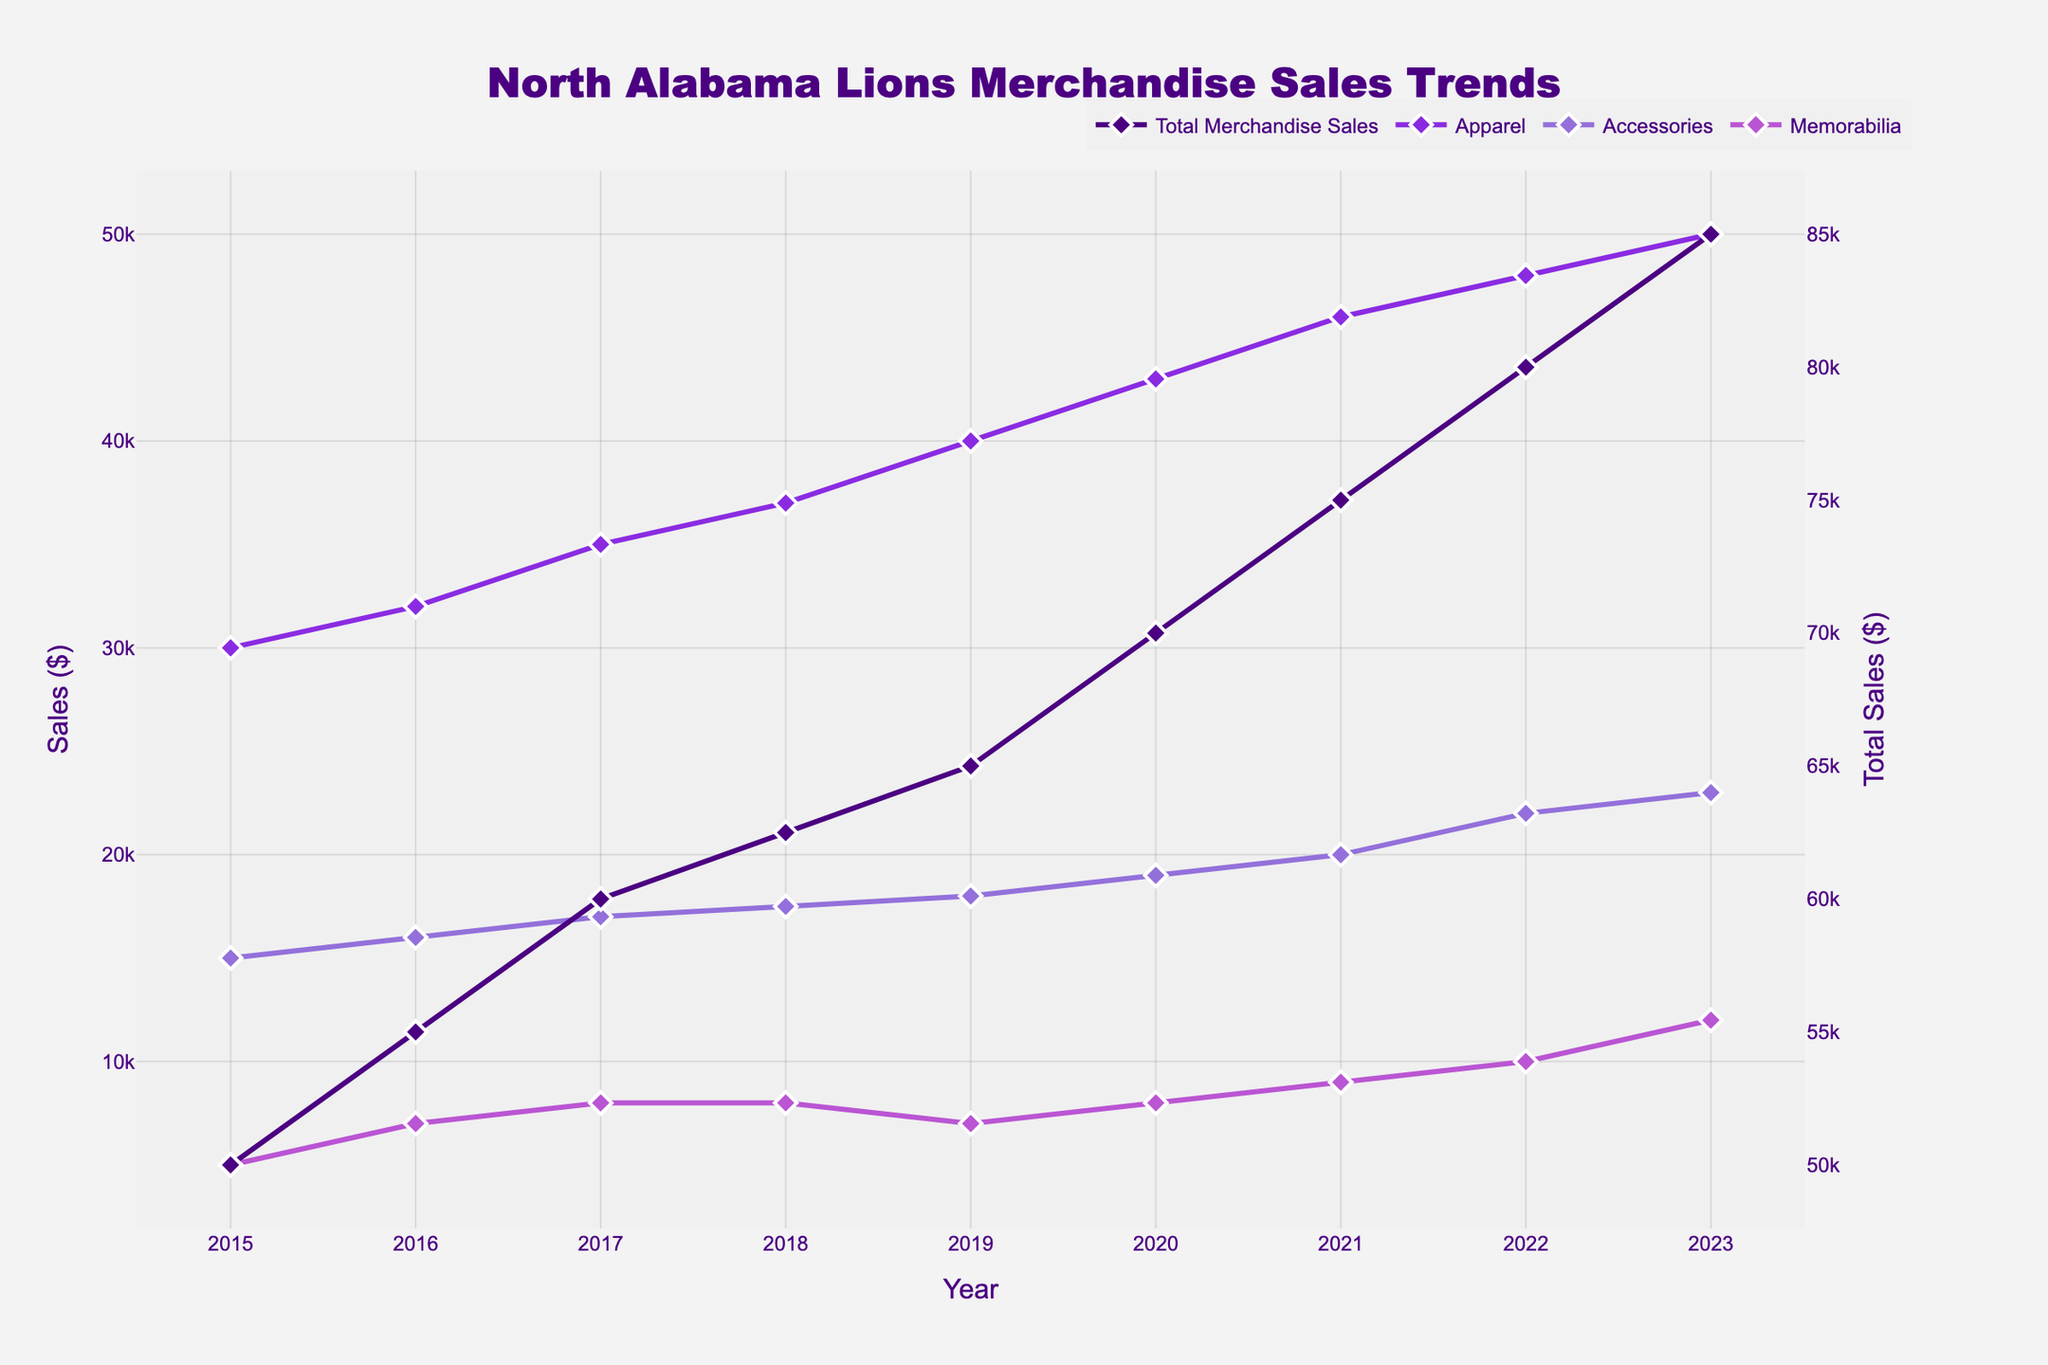How many years are covered in the plot? The x-axis of the plot indicates the years covered. By counting the data points or observing the range on the x-axis from the first to the last tick, we see that the years range from 2015 to 2023.
Answer: 9 What is the title of the plot? The plot has a title positioned at the top center. From the information given, the title is "North Alabama Lions Merchandise Sales Trends."
Answer: North Alabama Lions Merchandise Sales Trends Which type of merchandise had the highest sales in 2022? By looking at the y-values for each merchandise category in 2022 on the x-axis, the Apparel category had the highest value.
Answer: Apparel By how much did the total merchandise sales increase from 2015 to 2023? We need to note the Total Merchandise Sales values in 2015 and 2023, which are $50,000 and $85,000 respectively. Subtracting these values gives the increase: $85,000 - $50,000 = $35,000.
Answer: $35,000 What is the trend in sales for Apparel over the years? Following the line and markers for the Apparel category from 2015 to 2023 shows a steady upward trend, indicated by a continuous increase in sales each year.
Answer: Steady upward trend Which year had the lowest sales for Memorabilia? Observing the lines and markers for the Memorabilia category, the year with the lowest y-value is 2015, with sales of $5,000.
Answer: 2015 Are the total merchandise sales increasing arithmetically or at an accelerating rate? By observing the spacing and slope of the Total Merchandise Sales line, we see the slope increases over time, indicating that sales are increasing at an accelerating rate.
Answer: Accelerating rate How do the sales of Accessories compare to those of Memorabilia in 2023? By comparing the y-values in 2023 for Accessories and Memorabilia, Accessories had sales of $23,000 while Memorabilia had $12,000. Thus, Accessories had higher sales.
Answer: Accessories had higher sales What was the average sale of Accessories from 2015 to 2023? To calculate the average, sum the Annual Sales for Accessories: $15,000 + $16,000 + $17,000 + $17,500 + $18,000 + $19,000 + $20,000 + $22,000 + $23,000 = $167,500. Divide this by 9 years, giving an average of $167,500/9 ≈ $18,611.11.
Answer: $18,611.11 